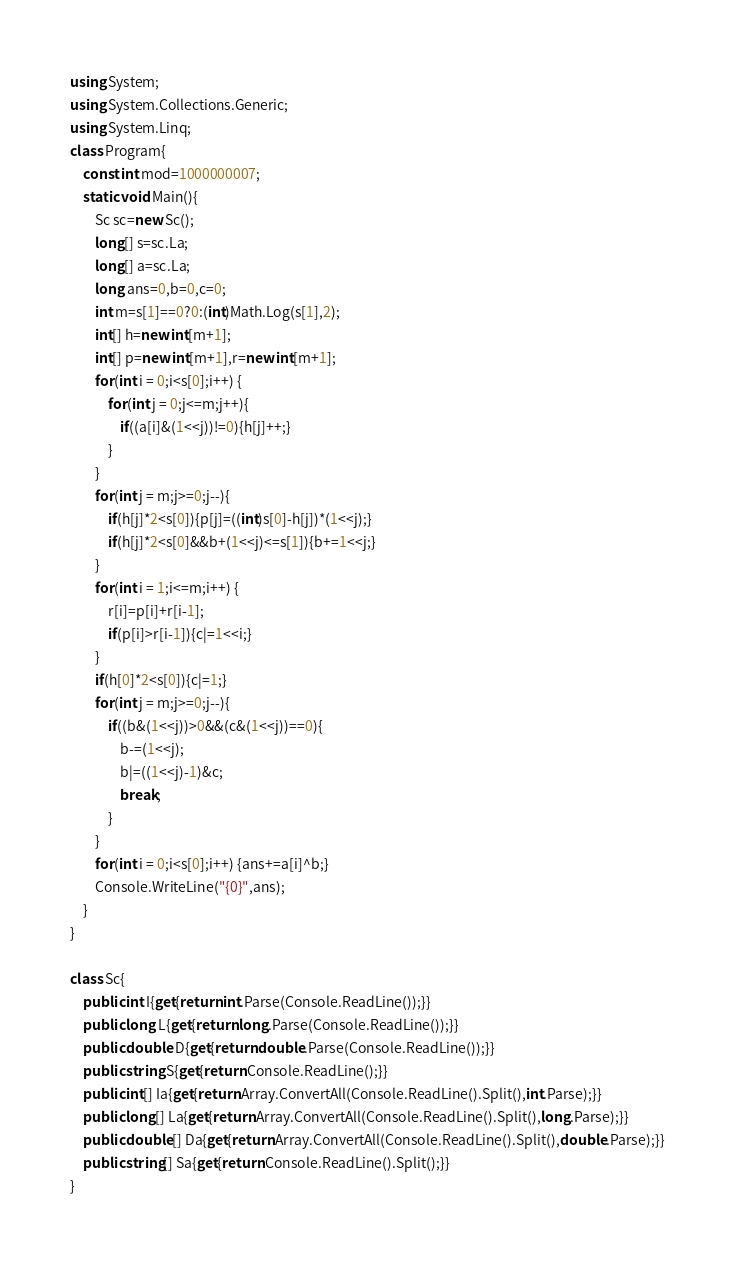Convert code to text. <code><loc_0><loc_0><loc_500><loc_500><_C#_>using System;
using System.Collections.Generic;
using System.Linq;
class Program{
	const int mod=1000000007;
	static void Main(){
		Sc sc=new Sc();
		long[] s=sc.La;
		long[] a=sc.La;
		long ans=0,b=0,c=0;
		int m=s[1]==0?0:(int)Math.Log(s[1],2);
		int[] h=new int[m+1];
		int[] p=new int[m+1],r=new int[m+1];
		for(int i = 0;i<s[0];i++) {
			for(int j = 0;j<=m;j++){
				if((a[i]&(1<<j))!=0){h[j]++;}
			}
		}
		for(int j = m;j>=0;j--){
			if(h[j]*2<s[0]){p[j]=((int)s[0]-h[j])*(1<<j);}
			if(h[j]*2<s[0]&&b+(1<<j)<=s[1]){b+=1<<j;}
		}
		for(int i = 1;i<=m;i++) {
			r[i]=p[i]+r[i-1];
			if(p[i]>r[i-1]){c|=1<<i;}
		}
		if(h[0]*2<s[0]){c|=1;}
		for(int j = m;j>=0;j--){
			if((b&(1<<j))>0&&(c&(1<<j))==0){
				b-=(1<<j);
				b|=((1<<j)-1)&c;
				break;
			}
		}
		for(int i = 0;i<s[0];i++) {ans+=a[i]^b;}
		Console.WriteLine("{0}",ans);
	}
}

class Sc{
	public int I{get{return int.Parse(Console.ReadLine());}}
	public long L{get{return long.Parse(Console.ReadLine());}}
	public double D{get{return double.Parse(Console.ReadLine());}}
	public string S{get{return Console.ReadLine();}}
	public int[] Ia{get{return Array.ConvertAll(Console.ReadLine().Split(),int.Parse);}}
	public long[] La{get{return Array.ConvertAll(Console.ReadLine().Split(),long.Parse);}}
	public double[] Da{get{return Array.ConvertAll(Console.ReadLine().Split(),double.Parse);}}
	public string[] Sa{get{return Console.ReadLine().Split();}}
}</code> 